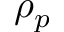Convert formula to latex. <formula><loc_0><loc_0><loc_500><loc_500>\rho _ { p }</formula> 